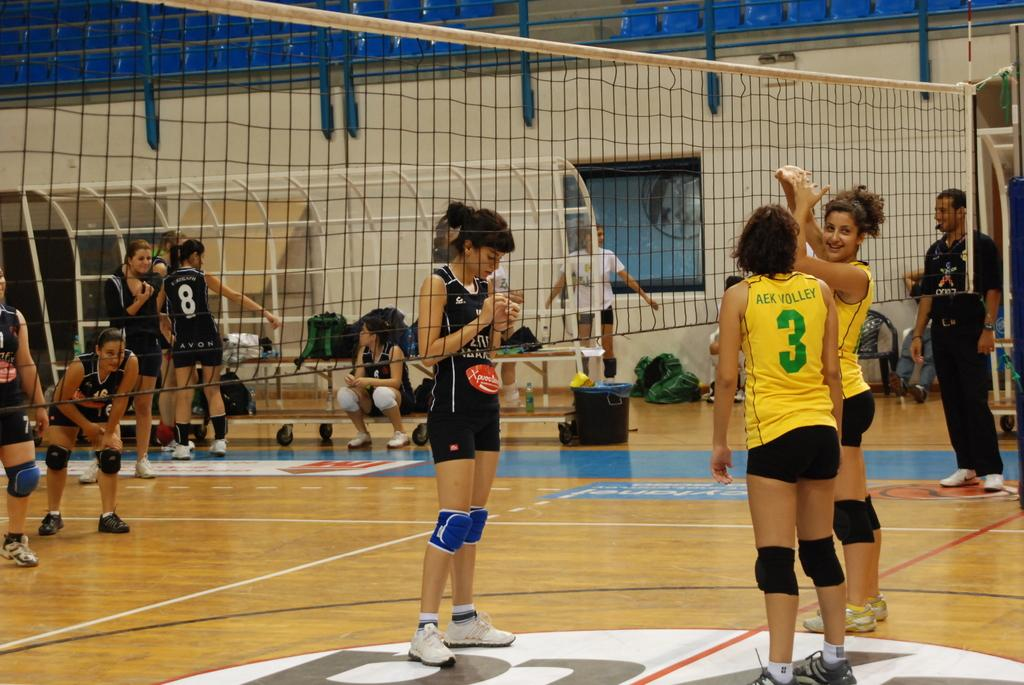<image>
Describe the image concisely. Volleyball players standing next to a net with one that has a number 3 on her jersey. 